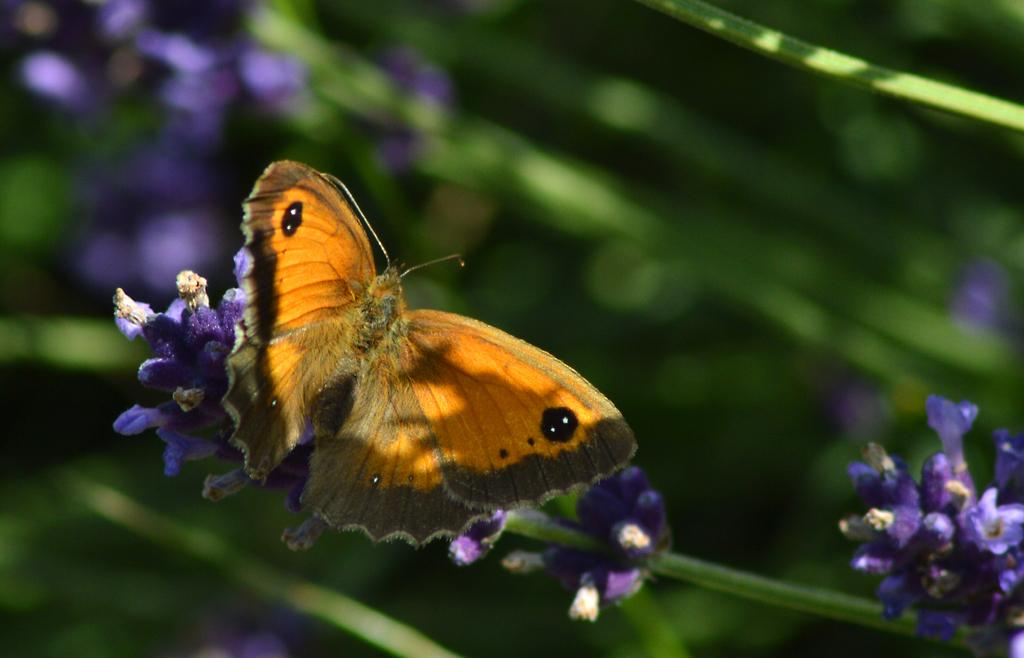What is depicted in the image at a microscopic level? There are atoms in the image. What type of living organisms can be seen in the image? There are flowers in the image. Can you describe the interaction between the butterfly and the flower in the image? There is a butterfly on a flower in the image. How would you describe the overall appearance of the image? The background of the image is blurred. Where is the sink located in the image? There is no sink present in the image. What type of hammer is being used to demonstrate an example in the image? There is no hammer or example present in the image. 